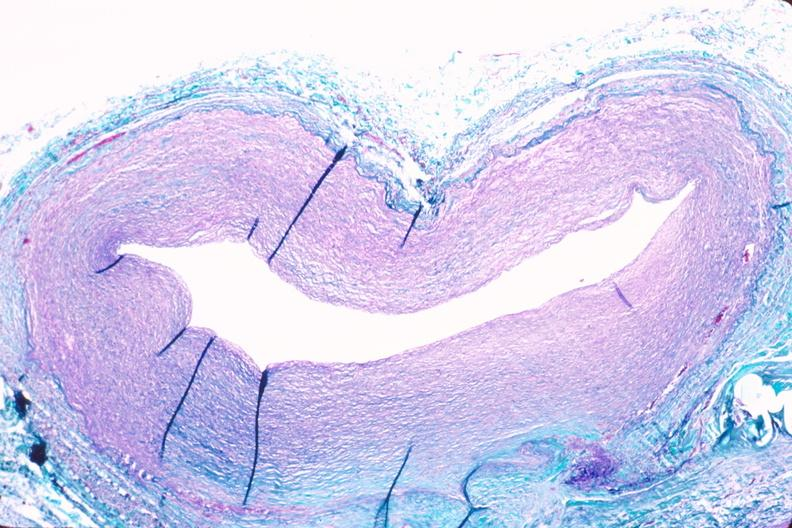s muscle atrophy present?
Answer the question using a single word or phrase. No 